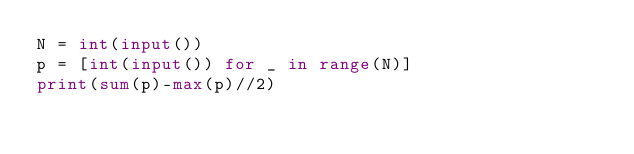Convert code to text. <code><loc_0><loc_0><loc_500><loc_500><_Python_>N = int(input())
p = [int(input()) for _ in range(N)]
print(sum(p)-max(p)//2)</code> 